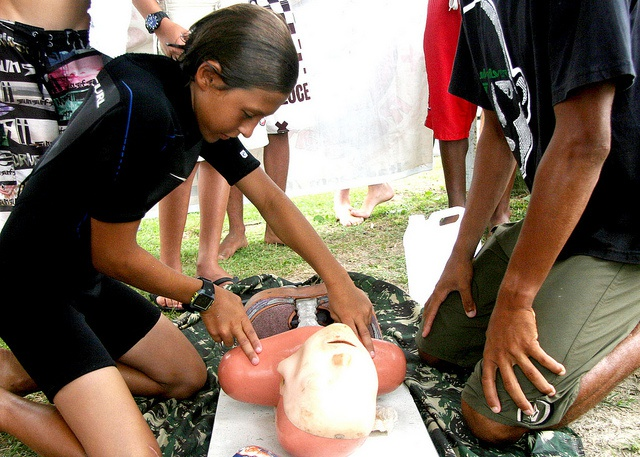Describe the objects in this image and their specific colors. I can see people in tan, black, salmon, maroon, and brown tones, people in tan, black, maroon, and gray tones, people in tan, black, lightgray, and gray tones, people in tan, brown, and maroon tones, and people in tan, brown, and salmon tones in this image. 